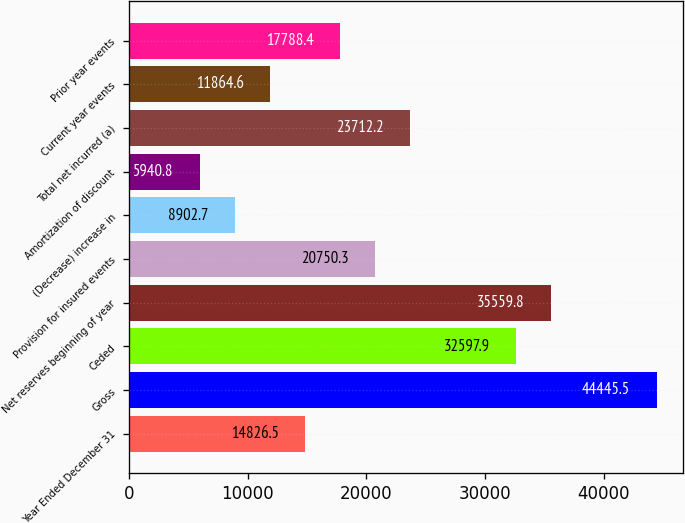Convert chart to OTSL. <chart><loc_0><loc_0><loc_500><loc_500><bar_chart><fcel>Year Ended December 31<fcel>Gross<fcel>Ceded<fcel>Net reserves beginning of year<fcel>Provision for insured events<fcel>(Decrease) increase in<fcel>Amortization of discount<fcel>Total net incurred (a)<fcel>Current year events<fcel>Prior year events<nl><fcel>14826.5<fcel>44445.5<fcel>32597.9<fcel>35559.8<fcel>20750.3<fcel>8902.7<fcel>5940.8<fcel>23712.2<fcel>11864.6<fcel>17788.4<nl></chart> 